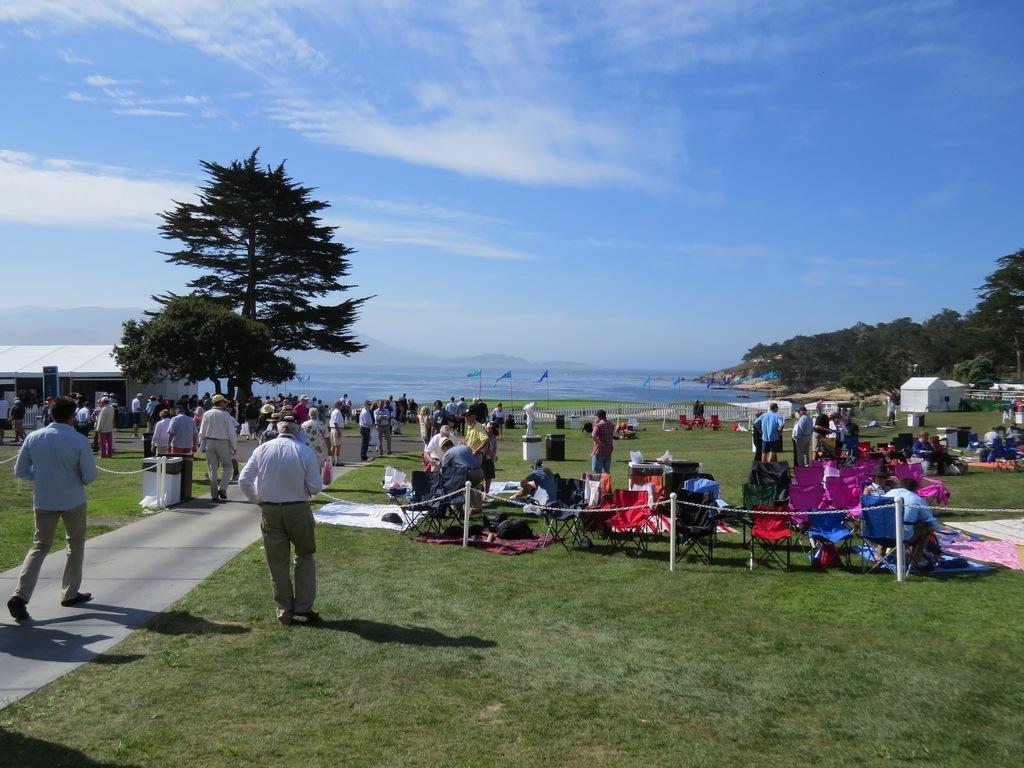Can you describe this image briefly? In this image I can see an open grass ground and on it I can see number of people are standing. On the right side of this image I can see number of poles, an iron chain, number of chairs and on it I can see few people are sitting. In the background I can see number of trees, number of flags, few buildings, water, clouds and the sky. In the front I can see few shadows on the ground. 